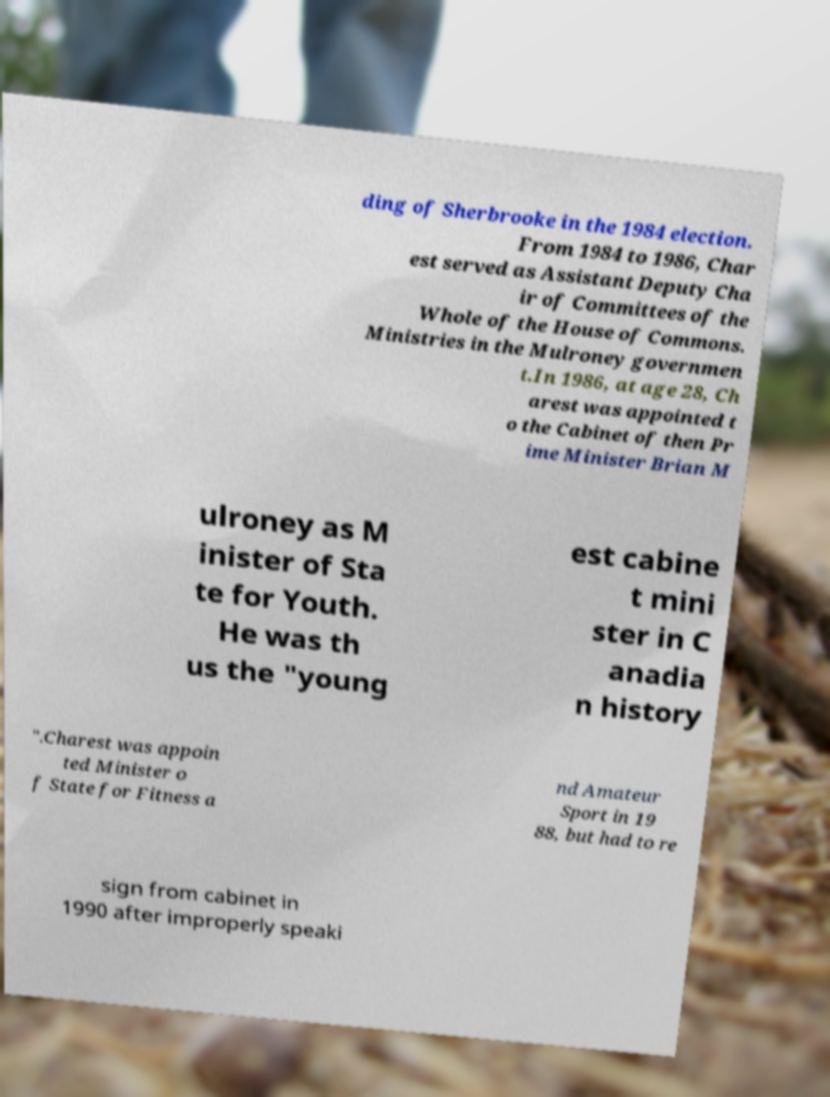I need the written content from this picture converted into text. Can you do that? ding of Sherbrooke in the 1984 election. From 1984 to 1986, Char est served as Assistant Deputy Cha ir of Committees of the Whole of the House of Commons. Ministries in the Mulroney governmen t.In 1986, at age 28, Ch arest was appointed t o the Cabinet of then Pr ime Minister Brian M ulroney as M inister of Sta te for Youth. He was th us the "young est cabine t mini ster in C anadia n history ".Charest was appoin ted Minister o f State for Fitness a nd Amateur Sport in 19 88, but had to re sign from cabinet in 1990 after improperly speaki 